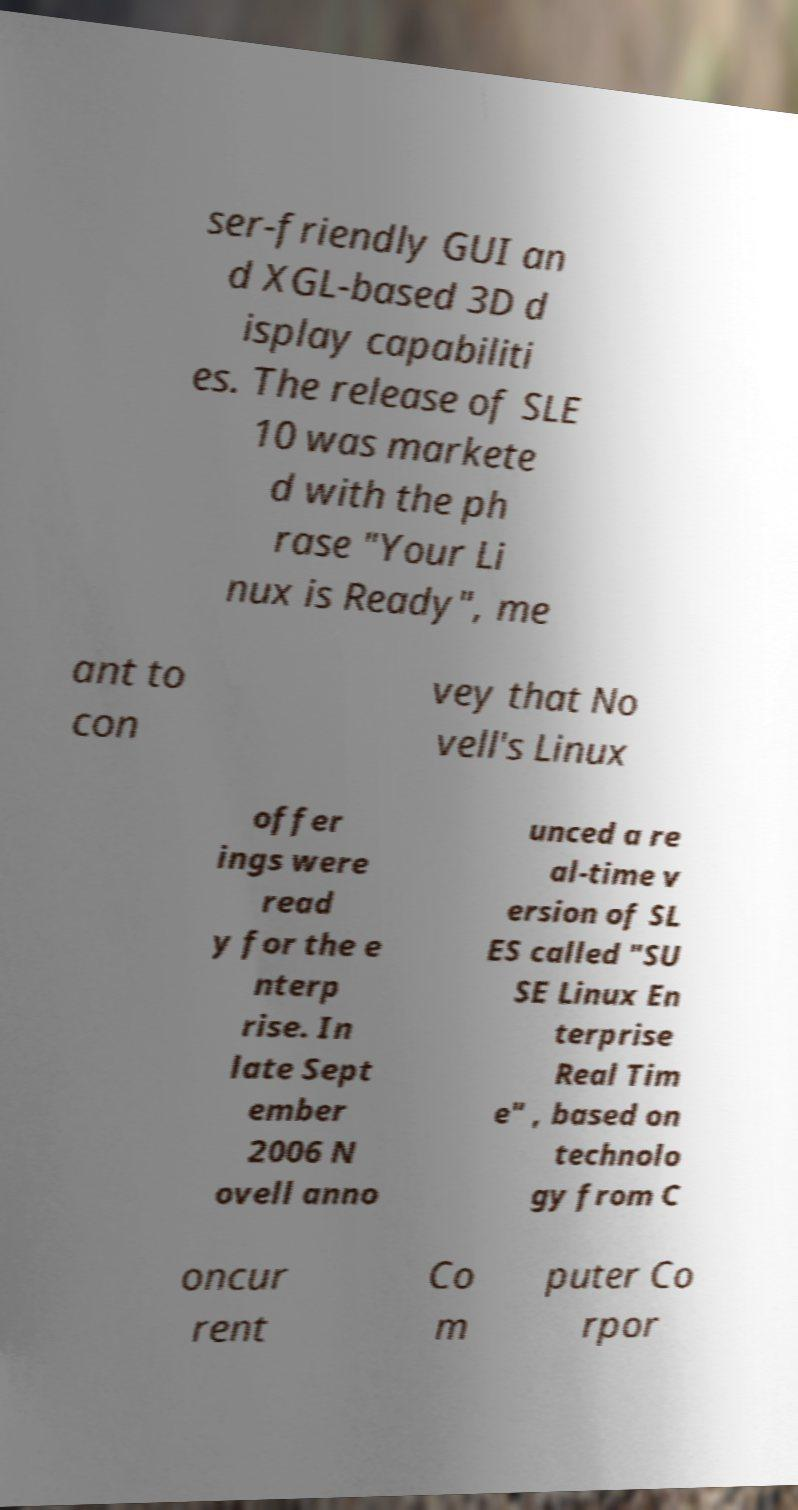What messages or text are displayed in this image? I need them in a readable, typed format. ser-friendly GUI an d XGL-based 3D d isplay capabiliti es. The release of SLE 10 was markete d with the ph rase "Your Li nux is Ready", me ant to con vey that No vell's Linux offer ings were read y for the e nterp rise. In late Sept ember 2006 N ovell anno unced a re al-time v ersion of SL ES called "SU SE Linux En terprise Real Tim e" , based on technolo gy from C oncur rent Co m puter Co rpor 